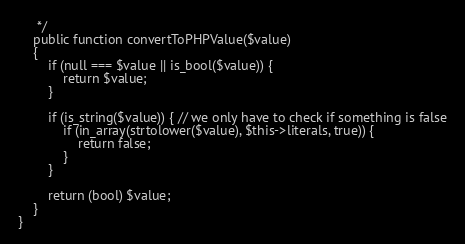Convert code to text. <code><loc_0><loc_0><loc_500><loc_500><_PHP_>     */
    public function convertToPHPValue($value)
    {
        if (null === $value || is_bool($value)) {
            return $value;
        }

        if (is_string($value)) { // we only have to check if something is false
            if (in_array(strtolower($value), $this->literals, true)) {
                return false;
            }
        }

        return (bool) $value;
    }
}
</code> 